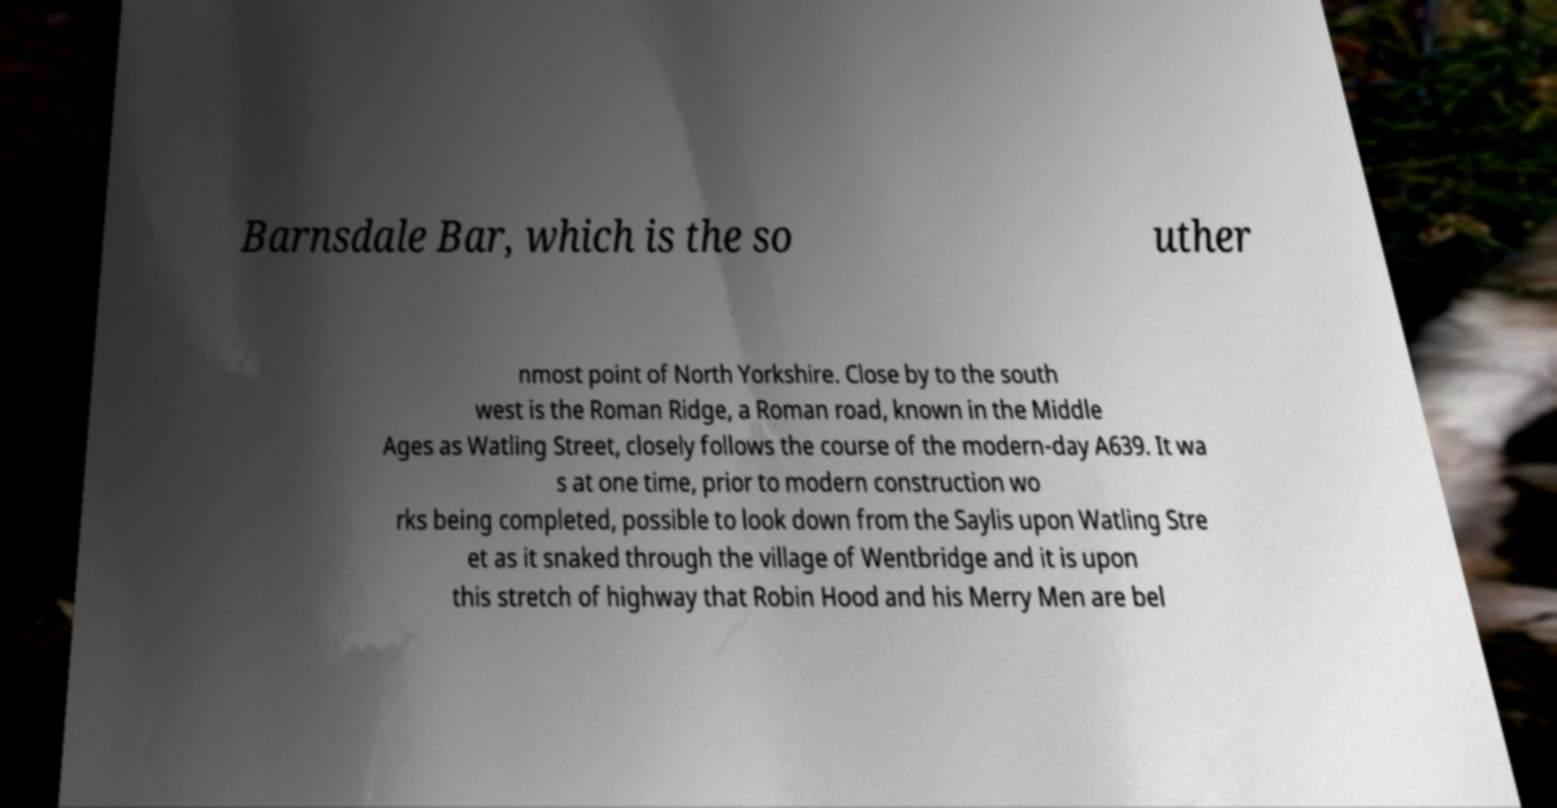Can you read and provide the text displayed in the image?This photo seems to have some interesting text. Can you extract and type it out for me? Barnsdale Bar, which is the so uther nmost point of North Yorkshire. Close by to the south west is the Roman Ridge, a Roman road, known in the Middle Ages as Watling Street, closely follows the course of the modern-day A639. It wa s at one time, prior to modern construction wo rks being completed, possible to look down from the Saylis upon Watling Stre et as it snaked through the village of Wentbridge and it is upon this stretch of highway that Robin Hood and his Merry Men are bel 